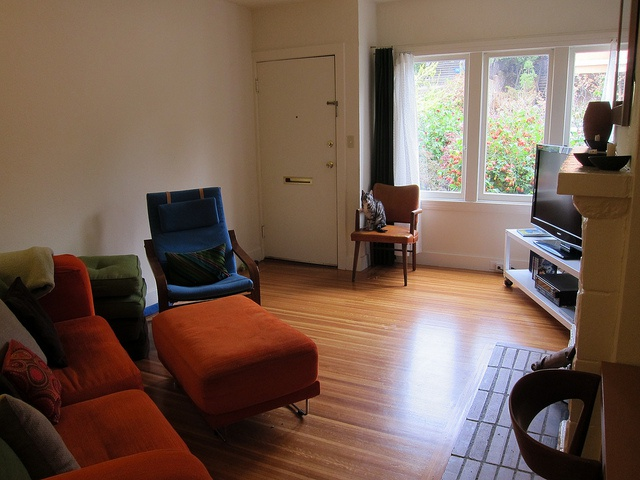Describe the objects in this image and their specific colors. I can see couch in gray, maroon, and black tones, chair in gray, black, navy, blue, and maroon tones, chair in gray, black, and maroon tones, tv in gray and black tones, and chair in gray, maroon, black, salmon, and brown tones in this image. 